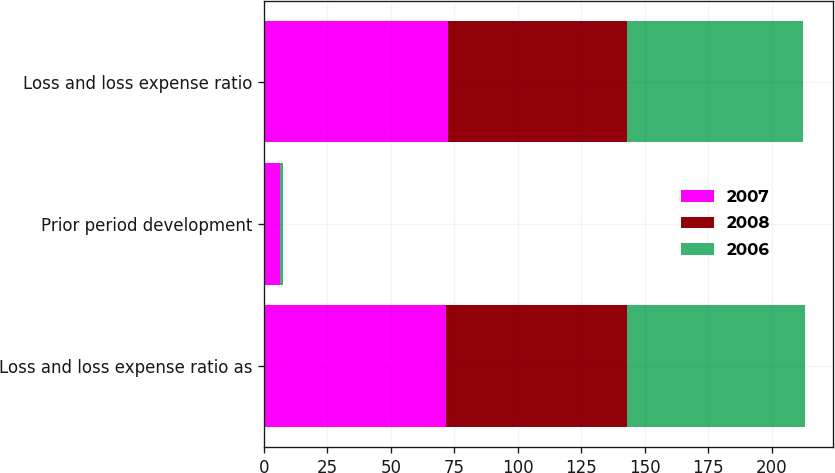Convert chart to OTSL. <chart><loc_0><loc_0><loc_500><loc_500><stacked_bar_chart><ecel><fcel>Loss and loss expense ratio as<fcel>Prior period development<fcel>Loss and loss expense ratio<nl><fcel>2007<fcel>71.8<fcel>6.2<fcel>72.6<nl><fcel>2008<fcel>71.1<fcel>0.2<fcel>70.6<nl><fcel>2006<fcel>70.4<fcel>1.2<fcel>69.2<nl></chart> 